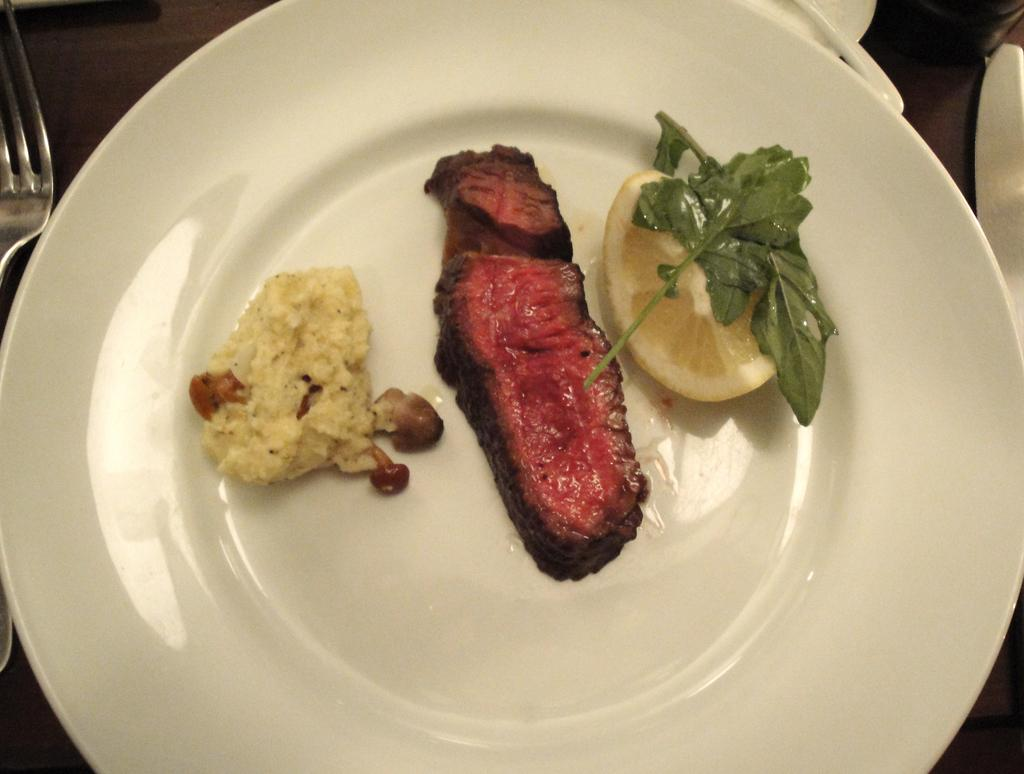What is on the plate in the image? A lemon and leaves are present on the plate in the image. Are there any food items on the plate? Yes, there are food items on the plate. What utensil can be seen in the image? A fork is visible in the image. What else is on the surface where the plate is placed? There are other objects on the surface. How many houses can be seen in the image? There are no houses present in the image. What type of cord is used to hold the pail in the image? There is no pail or cord present in the image. 